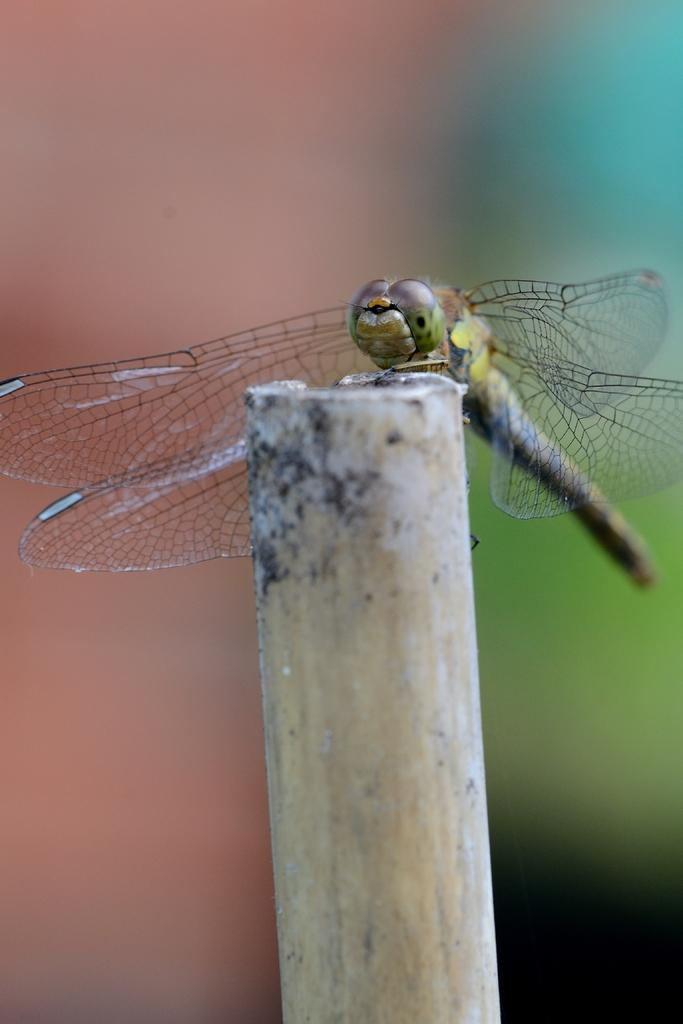What type of insect is present in the image? There is a dragonfly in the image. How many chickens are present in the image? There are no chickens present in the image; it features a dragonfly. What type of expansion is shown in the image? There is no expansion shown in the image; it features a dragonfly. 